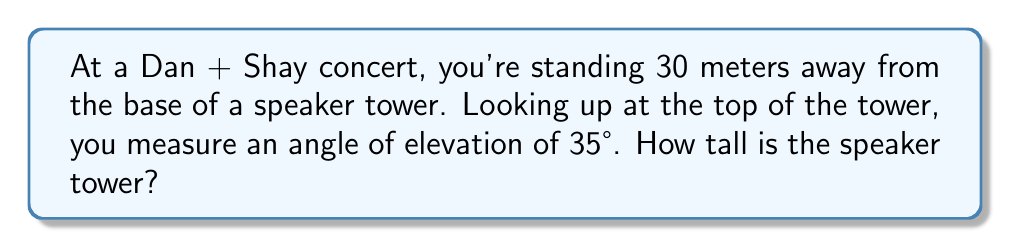Could you help me with this problem? Let's approach this step-by-step using trigonometry:

1) We can visualize this as a right triangle, where:
   - The base of the triangle is the distance from you to the tower (30 meters)
   - The height of the triangle is the height of the tower (what we're solving for)
   - The angle between the ground and your line of sight to the top of the tower is 35°

2) In this right triangle, we know:
   - The adjacent side (distance to the tower) = 30 meters
   - The angle = 35°
   - We need to find the opposite side (height of the tower)

3) The trigonometric ratio that relates the opposite side to the adjacent side is the tangent:

   $$\tan \theta = \frac{\text{opposite}}{\text{adjacent}}$$

4) Plugging in our known values:

   $$\tan 35° = \frac{\text{height}}{30}$$

5) To solve for the height, we multiply both sides by 30:

   $$30 \cdot \tan 35° = \text{height}$$

6) Using a calculator (or trigonometric tables):

   $$\text{height} = 30 \cdot \tan 35° \approx 30 \cdot 0.7002 \approx 21.006$$

7) Rounding to the nearest tenth:

   $$\text{height} \approx 21.0 \text{ meters}$$

[asy]
import geometry;

size(200);

pair A = (0,0);
pair B = (30,0);
pair C = (30,21);

draw(A--B--C--A);

label("30 m", (15,0), S);
label("21 m", (31,10.5), E);
label("35°", (1,1), NW);

draw(rightanglemark(A,B,C));
[/asy]
Answer: 21.0 meters 